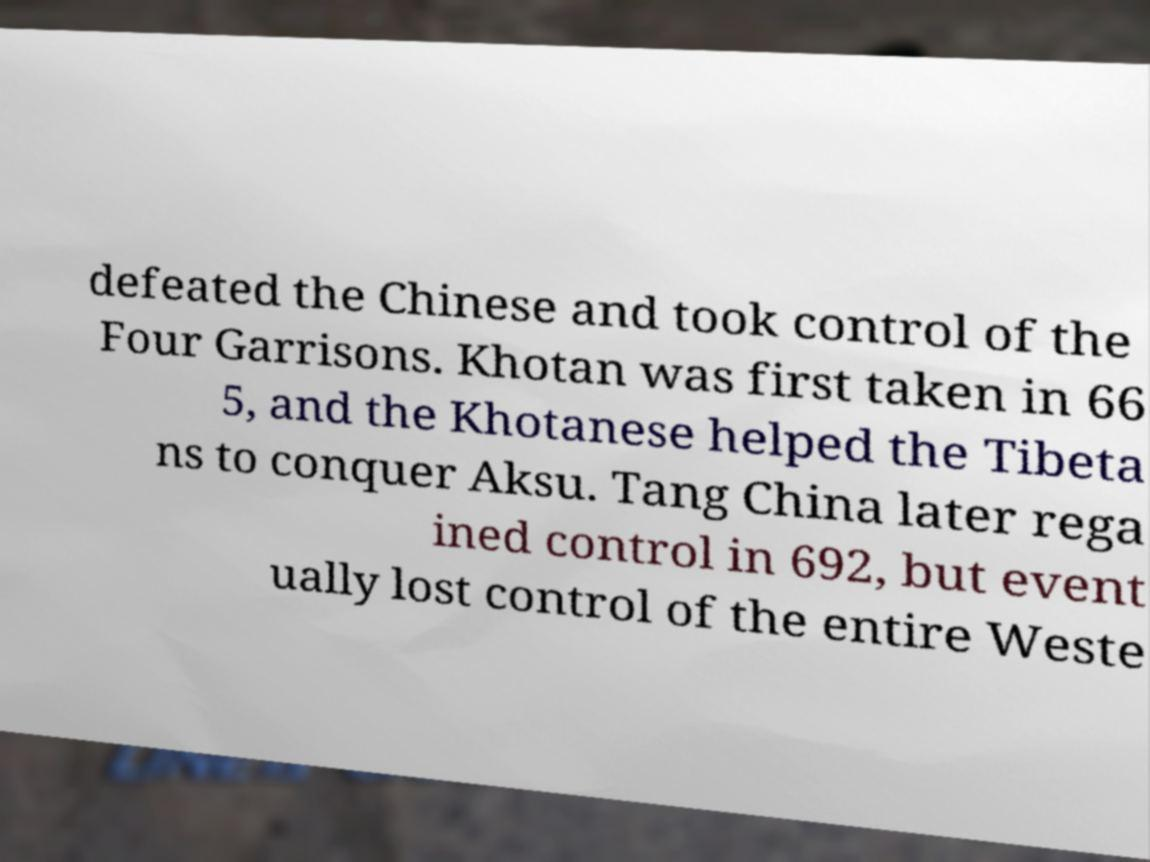For documentation purposes, I need the text within this image transcribed. Could you provide that? defeated the Chinese and took control of the Four Garrisons. Khotan was first taken in 66 5, and the Khotanese helped the Tibeta ns to conquer Aksu. Tang China later rega ined control in 692, but event ually lost control of the entire Weste 